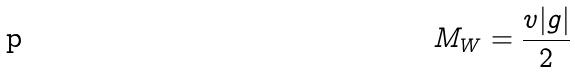Convert formula to latex. <formula><loc_0><loc_0><loc_500><loc_500>M _ { W } = \frac { v | g | } { 2 }</formula> 